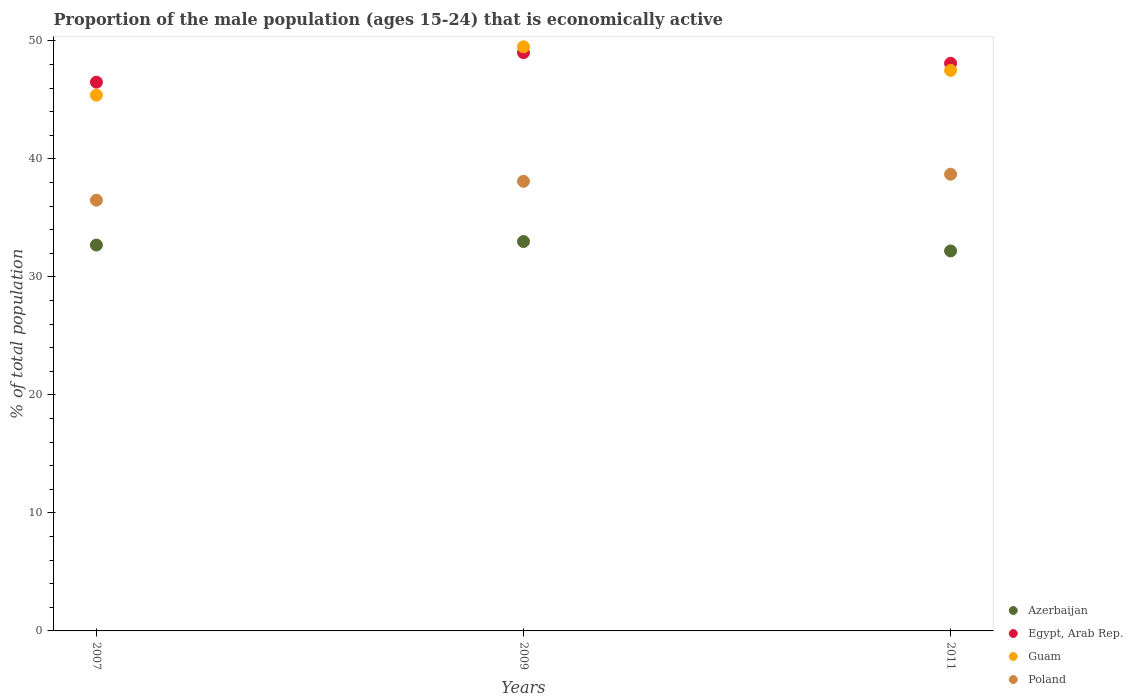How many different coloured dotlines are there?
Ensure brevity in your answer.  4. What is the proportion of the male population that is economically active in Guam in 2009?
Give a very brief answer. 49.5. Across all years, what is the maximum proportion of the male population that is economically active in Poland?
Make the answer very short. 38.7. Across all years, what is the minimum proportion of the male population that is economically active in Guam?
Offer a very short reply. 45.4. In which year was the proportion of the male population that is economically active in Poland minimum?
Your response must be concise. 2007. What is the total proportion of the male population that is economically active in Guam in the graph?
Offer a terse response. 142.4. What is the difference between the proportion of the male population that is economically active in Azerbaijan in 2007 and that in 2009?
Make the answer very short. -0.3. What is the average proportion of the male population that is economically active in Azerbaijan per year?
Your response must be concise. 32.63. In the year 2009, what is the difference between the proportion of the male population that is economically active in Azerbaijan and proportion of the male population that is economically active in Poland?
Your answer should be very brief. -5.1. What is the ratio of the proportion of the male population that is economically active in Guam in 2009 to that in 2011?
Your answer should be compact. 1.04. Is the proportion of the male population that is economically active in Azerbaijan in 2007 less than that in 2011?
Your answer should be compact. No. Is the difference between the proportion of the male population that is economically active in Azerbaijan in 2009 and 2011 greater than the difference between the proportion of the male population that is economically active in Poland in 2009 and 2011?
Your answer should be compact. Yes. What is the difference between the highest and the second highest proportion of the male population that is economically active in Guam?
Ensure brevity in your answer.  2. What is the difference between the highest and the lowest proportion of the male population that is economically active in Poland?
Offer a terse response. 2.2. In how many years, is the proportion of the male population that is economically active in Guam greater than the average proportion of the male population that is economically active in Guam taken over all years?
Make the answer very short. 2. Is it the case that in every year, the sum of the proportion of the male population that is economically active in Egypt, Arab Rep. and proportion of the male population that is economically active in Azerbaijan  is greater than the sum of proportion of the male population that is economically active in Poland and proportion of the male population that is economically active in Guam?
Provide a short and direct response. Yes. Is it the case that in every year, the sum of the proportion of the male population that is economically active in Poland and proportion of the male population that is economically active in Azerbaijan  is greater than the proportion of the male population that is economically active in Guam?
Provide a succinct answer. Yes. Is the proportion of the male population that is economically active in Azerbaijan strictly less than the proportion of the male population that is economically active in Egypt, Arab Rep. over the years?
Make the answer very short. Yes. What is the difference between two consecutive major ticks on the Y-axis?
Offer a very short reply. 10. Does the graph contain any zero values?
Your response must be concise. No. Does the graph contain grids?
Offer a terse response. No. Where does the legend appear in the graph?
Offer a terse response. Bottom right. What is the title of the graph?
Give a very brief answer. Proportion of the male population (ages 15-24) that is economically active. Does "Egypt, Arab Rep." appear as one of the legend labels in the graph?
Provide a short and direct response. Yes. What is the label or title of the X-axis?
Provide a succinct answer. Years. What is the label or title of the Y-axis?
Ensure brevity in your answer.  % of total population. What is the % of total population in Azerbaijan in 2007?
Keep it short and to the point. 32.7. What is the % of total population in Egypt, Arab Rep. in 2007?
Offer a very short reply. 46.5. What is the % of total population of Guam in 2007?
Offer a terse response. 45.4. What is the % of total population of Poland in 2007?
Offer a terse response. 36.5. What is the % of total population of Egypt, Arab Rep. in 2009?
Offer a very short reply. 49. What is the % of total population of Guam in 2009?
Offer a terse response. 49.5. What is the % of total population in Poland in 2009?
Keep it short and to the point. 38.1. What is the % of total population in Azerbaijan in 2011?
Provide a short and direct response. 32.2. What is the % of total population in Egypt, Arab Rep. in 2011?
Your answer should be very brief. 48.1. What is the % of total population in Guam in 2011?
Ensure brevity in your answer.  47.5. What is the % of total population of Poland in 2011?
Your answer should be compact. 38.7. Across all years, what is the maximum % of total population in Egypt, Arab Rep.?
Provide a succinct answer. 49. Across all years, what is the maximum % of total population in Guam?
Offer a very short reply. 49.5. Across all years, what is the maximum % of total population in Poland?
Give a very brief answer. 38.7. Across all years, what is the minimum % of total population in Azerbaijan?
Offer a very short reply. 32.2. Across all years, what is the minimum % of total population in Egypt, Arab Rep.?
Offer a terse response. 46.5. Across all years, what is the minimum % of total population in Guam?
Your response must be concise. 45.4. Across all years, what is the minimum % of total population of Poland?
Keep it short and to the point. 36.5. What is the total % of total population in Azerbaijan in the graph?
Keep it short and to the point. 97.9. What is the total % of total population of Egypt, Arab Rep. in the graph?
Give a very brief answer. 143.6. What is the total % of total population in Guam in the graph?
Give a very brief answer. 142.4. What is the total % of total population in Poland in the graph?
Keep it short and to the point. 113.3. What is the difference between the % of total population in Azerbaijan in 2007 and that in 2009?
Give a very brief answer. -0.3. What is the difference between the % of total population in Egypt, Arab Rep. in 2007 and that in 2009?
Your response must be concise. -2.5. What is the difference between the % of total population of Poland in 2007 and that in 2011?
Offer a terse response. -2.2. What is the difference between the % of total population of Azerbaijan in 2009 and that in 2011?
Keep it short and to the point. 0.8. What is the difference between the % of total population in Egypt, Arab Rep. in 2009 and that in 2011?
Offer a very short reply. 0.9. What is the difference between the % of total population in Guam in 2009 and that in 2011?
Make the answer very short. 2. What is the difference between the % of total population of Poland in 2009 and that in 2011?
Provide a succinct answer. -0.6. What is the difference between the % of total population of Azerbaijan in 2007 and the % of total population of Egypt, Arab Rep. in 2009?
Keep it short and to the point. -16.3. What is the difference between the % of total population of Azerbaijan in 2007 and the % of total population of Guam in 2009?
Your answer should be compact. -16.8. What is the difference between the % of total population of Azerbaijan in 2007 and the % of total population of Poland in 2009?
Offer a terse response. -5.4. What is the difference between the % of total population in Egypt, Arab Rep. in 2007 and the % of total population in Guam in 2009?
Keep it short and to the point. -3. What is the difference between the % of total population in Egypt, Arab Rep. in 2007 and the % of total population in Poland in 2009?
Offer a terse response. 8.4. What is the difference between the % of total population of Azerbaijan in 2007 and the % of total population of Egypt, Arab Rep. in 2011?
Your answer should be very brief. -15.4. What is the difference between the % of total population in Azerbaijan in 2007 and the % of total population in Guam in 2011?
Make the answer very short. -14.8. What is the difference between the % of total population of Guam in 2007 and the % of total population of Poland in 2011?
Your answer should be compact. 6.7. What is the difference between the % of total population in Azerbaijan in 2009 and the % of total population in Egypt, Arab Rep. in 2011?
Provide a short and direct response. -15.1. What is the difference between the % of total population of Egypt, Arab Rep. in 2009 and the % of total population of Poland in 2011?
Ensure brevity in your answer.  10.3. What is the average % of total population of Azerbaijan per year?
Make the answer very short. 32.63. What is the average % of total population of Egypt, Arab Rep. per year?
Your response must be concise. 47.87. What is the average % of total population of Guam per year?
Offer a terse response. 47.47. What is the average % of total population in Poland per year?
Your answer should be compact. 37.77. In the year 2007, what is the difference between the % of total population of Azerbaijan and % of total population of Egypt, Arab Rep.?
Keep it short and to the point. -13.8. In the year 2007, what is the difference between the % of total population of Azerbaijan and % of total population of Guam?
Give a very brief answer. -12.7. In the year 2007, what is the difference between the % of total population in Azerbaijan and % of total population in Poland?
Your response must be concise. -3.8. In the year 2007, what is the difference between the % of total population in Egypt, Arab Rep. and % of total population in Guam?
Offer a very short reply. 1.1. In the year 2007, what is the difference between the % of total population of Egypt, Arab Rep. and % of total population of Poland?
Give a very brief answer. 10. In the year 2009, what is the difference between the % of total population in Azerbaijan and % of total population in Guam?
Provide a succinct answer. -16.5. In the year 2009, what is the difference between the % of total population of Azerbaijan and % of total population of Poland?
Provide a succinct answer. -5.1. In the year 2009, what is the difference between the % of total population in Guam and % of total population in Poland?
Your answer should be compact. 11.4. In the year 2011, what is the difference between the % of total population in Azerbaijan and % of total population in Egypt, Arab Rep.?
Your answer should be very brief. -15.9. In the year 2011, what is the difference between the % of total population of Azerbaijan and % of total population of Guam?
Give a very brief answer. -15.3. In the year 2011, what is the difference between the % of total population in Azerbaijan and % of total population in Poland?
Offer a terse response. -6.5. What is the ratio of the % of total population in Azerbaijan in 2007 to that in 2009?
Keep it short and to the point. 0.99. What is the ratio of the % of total population in Egypt, Arab Rep. in 2007 to that in 2009?
Offer a terse response. 0.95. What is the ratio of the % of total population in Guam in 2007 to that in 2009?
Offer a terse response. 0.92. What is the ratio of the % of total population in Poland in 2007 to that in 2009?
Keep it short and to the point. 0.96. What is the ratio of the % of total population in Azerbaijan in 2007 to that in 2011?
Your answer should be very brief. 1.02. What is the ratio of the % of total population of Egypt, Arab Rep. in 2007 to that in 2011?
Your response must be concise. 0.97. What is the ratio of the % of total population in Guam in 2007 to that in 2011?
Make the answer very short. 0.96. What is the ratio of the % of total population in Poland in 2007 to that in 2011?
Offer a terse response. 0.94. What is the ratio of the % of total population in Azerbaijan in 2009 to that in 2011?
Offer a very short reply. 1.02. What is the ratio of the % of total population of Egypt, Arab Rep. in 2009 to that in 2011?
Ensure brevity in your answer.  1.02. What is the ratio of the % of total population in Guam in 2009 to that in 2011?
Provide a short and direct response. 1.04. What is the ratio of the % of total population in Poland in 2009 to that in 2011?
Offer a very short reply. 0.98. What is the difference between the highest and the second highest % of total population of Egypt, Arab Rep.?
Provide a short and direct response. 0.9. What is the difference between the highest and the second highest % of total population in Guam?
Keep it short and to the point. 2. What is the difference between the highest and the second highest % of total population of Poland?
Offer a very short reply. 0.6. What is the difference between the highest and the lowest % of total population of Azerbaijan?
Your answer should be very brief. 0.8. What is the difference between the highest and the lowest % of total population of Egypt, Arab Rep.?
Ensure brevity in your answer.  2.5. What is the difference between the highest and the lowest % of total population in Poland?
Give a very brief answer. 2.2. 